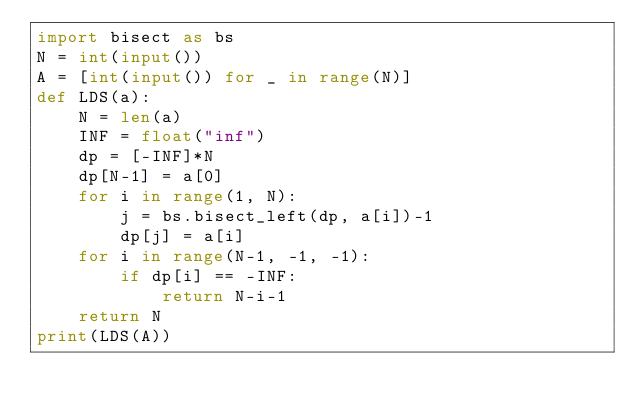<code> <loc_0><loc_0><loc_500><loc_500><_Python_>import bisect as bs
N = int(input())
A = [int(input()) for _ in range(N)]
def LDS(a):
    N = len(a)
    INF = float("inf")
    dp = [-INF]*N
    dp[N-1] = a[0]
    for i in range(1, N):
        j = bs.bisect_left(dp, a[i])-1
        dp[j] = a[i]
    for i in range(N-1, -1, -1):
        if dp[i] == -INF:
            return N-i-1
    return N
print(LDS(A))</code> 